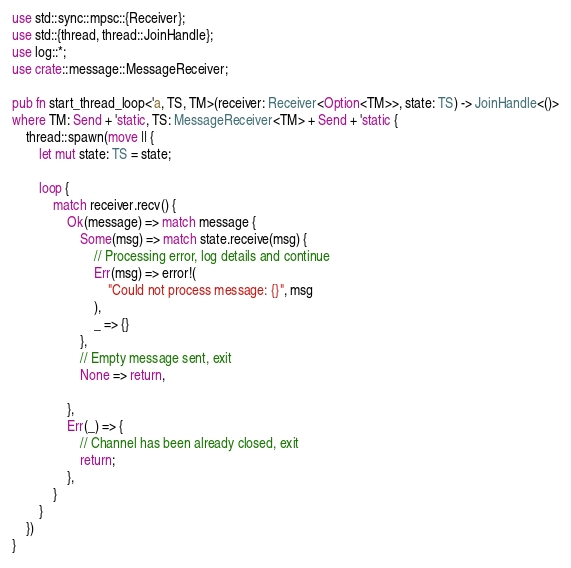Convert code to text. <code><loc_0><loc_0><loc_500><loc_500><_Rust_>use std::sync::mpsc::{Receiver};
use std::{thread, thread::JoinHandle};
use log::*;
use crate::message::MessageReceiver;

pub fn start_thread_loop<'a, TS, TM>(receiver: Receiver<Option<TM>>, state: TS) -> JoinHandle<()>
where TM: Send + 'static, TS: MessageReceiver<TM> + Send + 'static {
    thread::spawn(move || {
        let mut state: TS = state;

        loop {
            match receiver.recv() {
                Ok(message) => match message {
                    Some(msg) => match state.receive(msg) {
                        // Processing error, log details and continue
                        Err(msg) => error!(
                            "Could not process message: {}", msg
                        ),
                        _ => {}                        
                    },
                    // Empty message sent, exit
                    None => return,

                },
                Err(_) => {
                    // Channel has been already closed, exit
                    return;
                },
            }
        }
    })
}</code> 